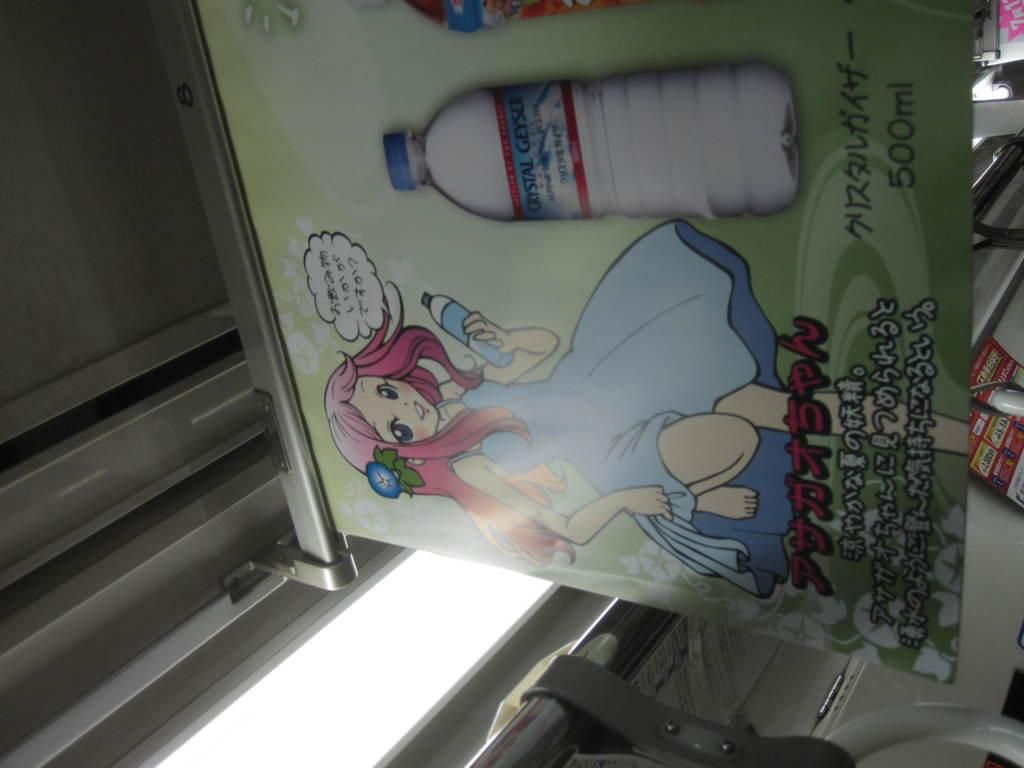What type of location is depicted in the image? The image is an inside view of a train. What can be seen on the walls of the train? There is a board in the image, which may contain information or advertisements. What are the passengers holding onto in the image? Strap hangers are present in the image, which passengers use to maintain their balance while the train is in motion. What other objects can be seen in the image? Rods are visible in the image, which may also be used for support or hanging belongings. Additionally, there is a paper in the image, which could be a newspaper, book, or document. Can you see a couple kissing in the image? No, there is no couple kissing in the image. What type of iron is being used to fold clothes in the image? There is no iron or folding of clothes present in the image; it depicts the inside of a train. 